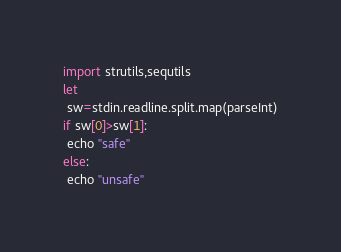<code> <loc_0><loc_0><loc_500><loc_500><_Nim_>import strutils,sequtils
let
 sw=stdin.readline.split.map(parseInt)
if sw[0]>sw[1]:
 echo "safe"
else:
 echo "unsafe"</code> 